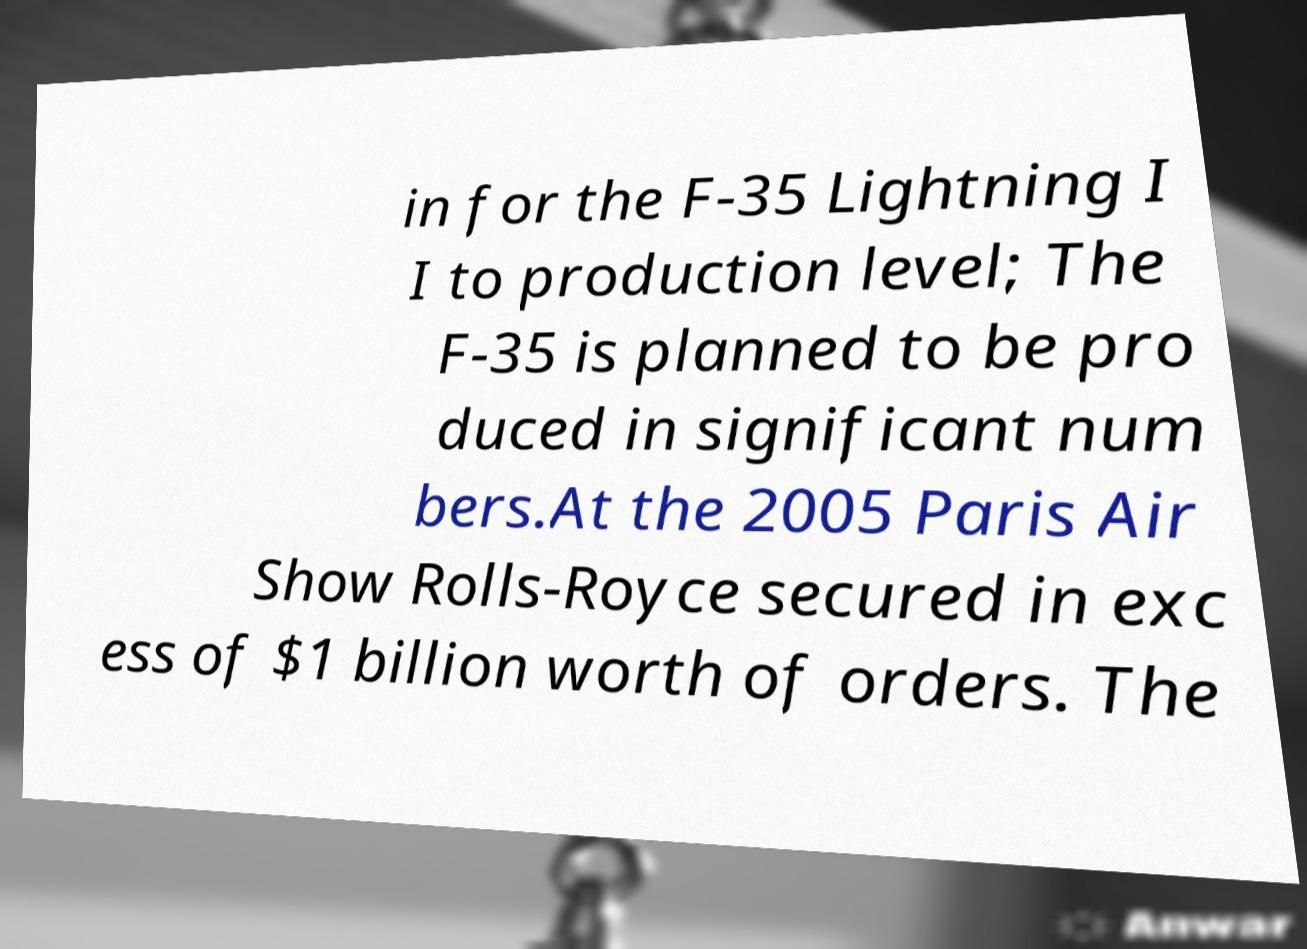Could you extract and type out the text from this image? in for the F-35 Lightning I I to production level; The F-35 is planned to be pro duced in significant num bers.At the 2005 Paris Air Show Rolls-Royce secured in exc ess of $1 billion worth of orders. The 